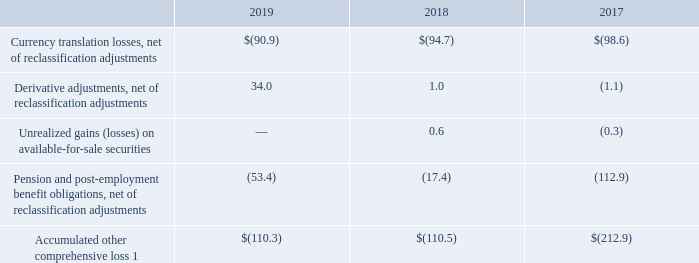Comprehensive Income — Comprehensive income includes net income, currency translation adjustments, certain derivative-related activity, changes in the value of available-for-sale investments (prior to the adoption of Accounting Standards Update ("ASU") 2016-01), and changes in prior service cost and net actuarial gains (losses) from pension (for amounts not in excess of the 10% "corridor") and postretirement health care plans. On foreign investments we deem to be essentially permanent in nature, we do not provide for taxes on currency translation adjustments arising from converting an investment denominated in a foreign currency to U.S. dollars. When we determine that a foreign investment, as well as undistributed earnings, are no longer permanent in nature, estimated taxes will be provided for the related deferred tax liability (asset), if any, resulting from currency translation adjustments.
The following table details the accumulated balances for each component of other comprehensive income, net of tax:
1 Net of unrealized gains on available-for-sale securities reclassified to retained earnings as a result of the adoption of ASU 2016-01 in fiscal 2019 and net of stranded tax effects from change in tax rate as a result of the early adoption of ASU 2018-02 in fiscal 2018 in the amount of $0.6 million and $17.4 million, respectively.
Notes to Consolidated Financial Statements - (Continued) Fiscal Years Ended May 26, 2019, May 27, 2018, and May 28, 2017 (columnar dollars in millions except per share amounts)
What does comprehensive income comprise of? Net income, currency translation adjustments, certain derivative-related activity, changes in the value of available-for-sale investments (prior to the adoption of accounting standards update ("asu") 2016-01), and changes in prior service cost and net actuarial gains (losses) from pension (for amounts not in excess of the 10% "corridor") and postretirement health care plans. What does the table show us? The accumulated balances for each component of other comprehensive income, net of tax. What are the balances for derivative adjustments (net of reclassification adjustments, in millions) for 2017, 2018 and 2019, respectively? (1.1), 1.0, 34.0. What is the percentage change of accumulated other comprehensive loss in 2018 compared to 2017?
Answer scale should be: percent. (-110.5-(-212.9))/(-212.9) 
Answer: -48.1. What are the proportion of currency translation losses and derivative adjustments over accumulated other comprehensive loss in 2017? (-98.6+(-1.1))/(-212.9) 
Answer: 0.47. What is the total balance of pension and post-employment benefit obligations from 2017 to 2019?
Answer scale should be: million. -112.9+(-17.4)+(-53.4) 
Answer: -183.7. 